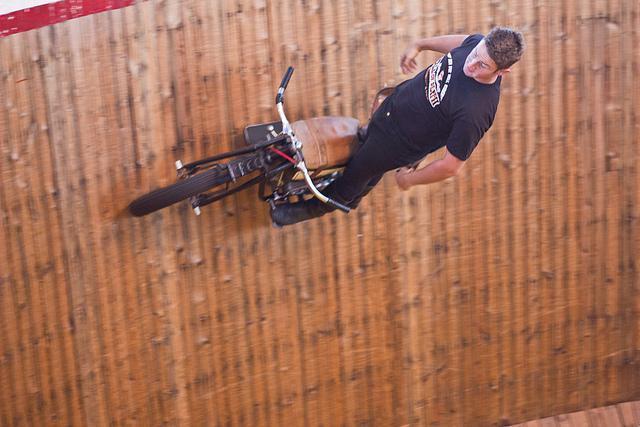How many motor vehicles have orange paint?
Give a very brief answer. 0. 